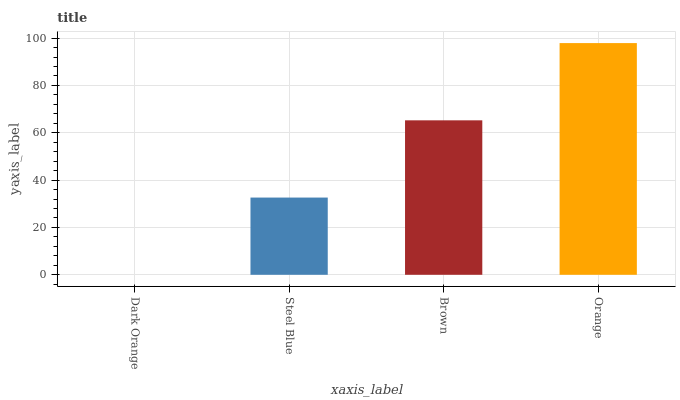Is Dark Orange the minimum?
Answer yes or no. Yes. Is Orange the maximum?
Answer yes or no. Yes. Is Steel Blue the minimum?
Answer yes or no. No. Is Steel Blue the maximum?
Answer yes or no. No. Is Steel Blue greater than Dark Orange?
Answer yes or no. Yes. Is Dark Orange less than Steel Blue?
Answer yes or no. Yes. Is Dark Orange greater than Steel Blue?
Answer yes or no. No. Is Steel Blue less than Dark Orange?
Answer yes or no. No. Is Brown the high median?
Answer yes or no. Yes. Is Steel Blue the low median?
Answer yes or no. Yes. Is Dark Orange the high median?
Answer yes or no. No. Is Orange the low median?
Answer yes or no. No. 